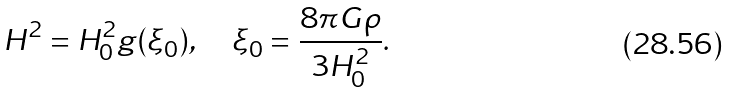<formula> <loc_0><loc_0><loc_500><loc_500>H ^ { 2 } = H _ { 0 } ^ { 2 } g ( \xi _ { 0 } ) , \quad \xi _ { 0 } = \frac { 8 \pi G \rho } { 3 H _ { 0 } ^ { 2 } } .</formula> 